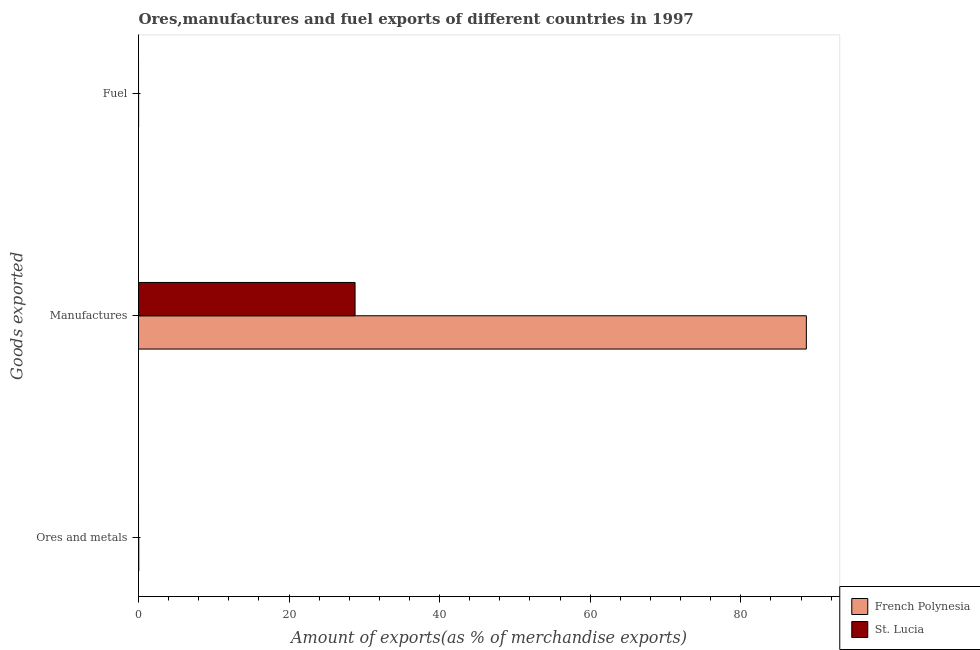How many different coloured bars are there?
Offer a terse response. 2. How many groups of bars are there?
Provide a succinct answer. 3. How many bars are there on the 1st tick from the top?
Keep it short and to the point. 2. What is the label of the 1st group of bars from the top?
Keep it short and to the point. Fuel. What is the percentage of ores and metals exports in French Polynesia?
Keep it short and to the point. 0.04. Across all countries, what is the maximum percentage of ores and metals exports?
Ensure brevity in your answer.  0.04. Across all countries, what is the minimum percentage of ores and metals exports?
Keep it short and to the point. 0. In which country was the percentage of ores and metals exports maximum?
Keep it short and to the point. French Polynesia. In which country was the percentage of ores and metals exports minimum?
Offer a terse response. St. Lucia. What is the total percentage of fuel exports in the graph?
Your answer should be very brief. 0.01. What is the difference between the percentage of fuel exports in French Polynesia and that in St. Lucia?
Ensure brevity in your answer.  0.01. What is the difference between the percentage of manufactures exports in St. Lucia and the percentage of fuel exports in French Polynesia?
Give a very brief answer. 28.75. What is the average percentage of ores and metals exports per country?
Offer a terse response. 0.02. What is the difference between the percentage of ores and metals exports and percentage of fuel exports in French Polynesia?
Keep it short and to the point. 0.02. What is the ratio of the percentage of fuel exports in French Polynesia to that in St. Lucia?
Provide a succinct answer. 16.12. Is the percentage of fuel exports in St. Lucia less than that in French Polynesia?
Your answer should be compact. Yes. What is the difference between the highest and the second highest percentage of ores and metals exports?
Make the answer very short. 0.04. What is the difference between the highest and the lowest percentage of fuel exports?
Make the answer very short. 0.01. In how many countries, is the percentage of ores and metals exports greater than the average percentage of ores and metals exports taken over all countries?
Give a very brief answer. 1. What does the 2nd bar from the top in Ores and metals represents?
Provide a short and direct response. French Polynesia. What does the 2nd bar from the bottom in Fuel represents?
Ensure brevity in your answer.  St. Lucia. Is it the case that in every country, the sum of the percentage of ores and metals exports and percentage of manufactures exports is greater than the percentage of fuel exports?
Offer a terse response. Yes. Are the values on the major ticks of X-axis written in scientific E-notation?
Provide a succinct answer. No. Does the graph contain grids?
Offer a terse response. No. How many legend labels are there?
Offer a very short reply. 2. What is the title of the graph?
Make the answer very short. Ores,manufactures and fuel exports of different countries in 1997. What is the label or title of the X-axis?
Make the answer very short. Amount of exports(as % of merchandise exports). What is the label or title of the Y-axis?
Give a very brief answer. Goods exported. What is the Amount of exports(as % of merchandise exports) of French Polynesia in Ores and metals?
Offer a very short reply. 0.04. What is the Amount of exports(as % of merchandise exports) of St. Lucia in Ores and metals?
Ensure brevity in your answer.  0. What is the Amount of exports(as % of merchandise exports) in French Polynesia in Manufactures?
Give a very brief answer. 88.71. What is the Amount of exports(as % of merchandise exports) in St. Lucia in Manufactures?
Offer a terse response. 28.76. What is the Amount of exports(as % of merchandise exports) in French Polynesia in Fuel?
Ensure brevity in your answer.  0.01. What is the Amount of exports(as % of merchandise exports) in St. Lucia in Fuel?
Give a very brief answer. 0. Across all Goods exported, what is the maximum Amount of exports(as % of merchandise exports) of French Polynesia?
Keep it short and to the point. 88.71. Across all Goods exported, what is the maximum Amount of exports(as % of merchandise exports) in St. Lucia?
Give a very brief answer. 28.76. Across all Goods exported, what is the minimum Amount of exports(as % of merchandise exports) in French Polynesia?
Ensure brevity in your answer.  0.01. Across all Goods exported, what is the minimum Amount of exports(as % of merchandise exports) in St. Lucia?
Ensure brevity in your answer.  0. What is the total Amount of exports(as % of merchandise exports) in French Polynesia in the graph?
Provide a short and direct response. 88.76. What is the total Amount of exports(as % of merchandise exports) in St. Lucia in the graph?
Provide a short and direct response. 28.77. What is the difference between the Amount of exports(as % of merchandise exports) of French Polynesia in Ores and metals and that in Manufactures?
Give a very brief answer. -88.67. What is the difference between the Amount of exports(as % of merchandise exports) of St. Lucia in Ores and metals and that in Manufactures?
Make the answer very short. -28.76. What is the difference between the Amount of exports(as % of merchandise exports) in French Polynesia in Ores and metals and that in Fuel?
Make the answer very short. 0.02. What is the difference between the Amount of exports(as % of merchandise exports) in St. Lucia in Ores and metals and that in Fuel?
Your answer should be very brief. -0. What is the difference between the Amount of exports(as % of merchandise exports) in French Polynesia in Manufactures and that in Fuel?
Your answer should be compact. 88.7. What is the difference between the Amount of exports(as % of merchandise exports) of St. Lucia in Manufactures and that in Fuel?
Make the answer very short. 28.76. What is the difference between the Amount of exports(as % of merchandise exports) of French Polynesia in Ores and metals and the Amount of exports(as % of merchandise exports) of St. Lucia in Manufactures?
Make the answer very short. -28.73. What is the difference between the Amount of exports(as % of merchandise exports) of French Polynesia in Ores and metals and the Amount of exports(as % of merchandise exports) of St. Lucia in Fuel?
Your response must be concise. 0.04. What is the difference between the Amount of exports(as % of merchandise exports) in French Polynesia in Manufactures and the Amount of exports(as % of merchandise exports) in St. Lucia in Fuel?
Offer a terse response. 88.71. What is the average Amount of exports(as % of merchandise exports) in French Polynesia per Goods exported?
Keep it short and to the point. 29.59. What is the average Amount of exports(as % of merchandise exports) of St. Lucia per Goods exported?
Give a very brief answer. 9.59. What is the difference between the Amount of exports(as % of merchandise exports) of French Polynesia and Amount of exports(as % of merchandise exports) of St. Lucia in Ores and metals?
Ensure brevity in your answer.  0.04. What is the difference between the Amount of exports(as % of merchandise exports) of French Polynesia and Amount of exports(as % of merchandise exports) of St. Lucia in Manufactures?
Ensure brevity in your answer.  59.95. What is the difference between the Amount of exports(as % of merchandise exports) of French Polynesia and Amount of exports(as % of merchandise exports) of St. Lucia in Fuel?
Your response must be concise. 0.01. What is the ratio of the Amount of exports(as % of merchandise exports) of French Polynesia in Ores and metals to that in Manufactures?
Offer a terse response. 0. What is the ratio of the Amount of exports(as % of merchandise exports) of French Polynesia in Ores and metals to that in Fuel?
Your answer should be compact. 2.73. What is the ratio of the Amount of exports(as % of merchandise exports) of St. Lucia in Ores and metals to that in Fuel?
Make the answer very short. 0.35. What is the ratio of the Amount of exports(as % of merchandise exports) of French Polynesia in Manufactures to that in Fuel?
Your response must be concise. 6745.48. What is the ratio of the Amount of exports(as % of merchandise exports) in St. Lucia in Manufactures to that in Fuel?
Provide a short and direct response. 3.53e+04. What is the difference between the highest and the second highest Amount of exports(as % of merchandise exports) of French Polynesia?
Provide a short and direct response. 88.67. What is the difference between the highest and the second highest Amount of exports(as % of merchandise exports) in St. Lucia?
Provide a succinct answer. 28.76. What is the difference between the highest and the lowest Amount of exports(as % of merchandise exports) in French Polynesia?
Offer a terse response. 88.7. What is the difference between the highest and the lowest Amount of exports(as % of merchandise exports) in St. Lucia?
Your answer should be compact. 28.76. 